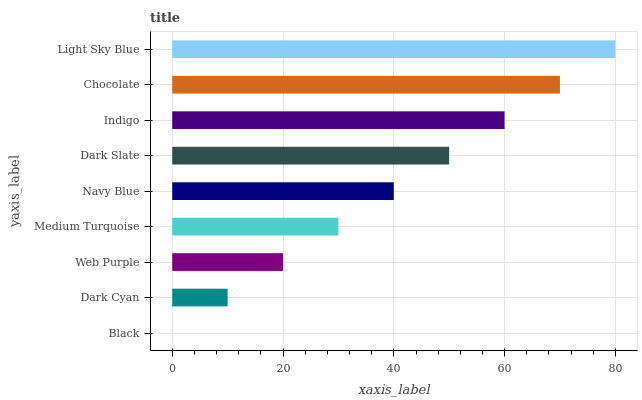Is Black the minimum?
Answer yes or no. Yes. Is Light Sky Blue the maximum?
Answer yes or no. Yes. Is Dark Cyan the minimum?
Answer yes or no. No. Is Dark Cyan the maximum?
Answer yes or no. No. Is Dark Cyan greater than Black?
Answer yes or no. Yes. Is Black less than Dark Cyan?
Answer yes or no. Yes. Is Black greater than Dark Cyan?
Answer yes or no. No. Is Dark Cyan less than Black?
Answer yes or no. No. Is Navy Blue the high median?
Answer yes or no. Yes. Is Navy Blue the low median?
Answer yes or no. Yes. Is Dark Cyan the high median?
Answer yes or no. No. Is Black the low median?
Answer yes or no. No. 